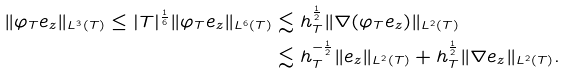<formula> <loc_0><loc_0><loc_500><loc_500>\| \varphi _ { T } e _ { z } \| _ { L ^ { 3 } ( T ) } \leq | T | ^ { \frac { 1 } { 6 } } \| \varphi _ { T } e _ { z } \| _ { L ^ { 6 } ( T ) } & \lesssim h _ { T } ^ { \frac { 1 } { 2 } } \| \nabla ( \varphi _ { T } e _ { z } ) \| _ { L ^ { 2 } ( T ) } \\ & \lesssim h _ { T } ^ { - \frac { 1 } { 2 } } \| e _ { z } \| _ { L ^ { 2 } ( T ) } + h _ { T } ^ { \frac { 1 } { 2 } } \| \nabla e _ { z } \| _ { L ^ { 2 } ( T ) } .</formula> 